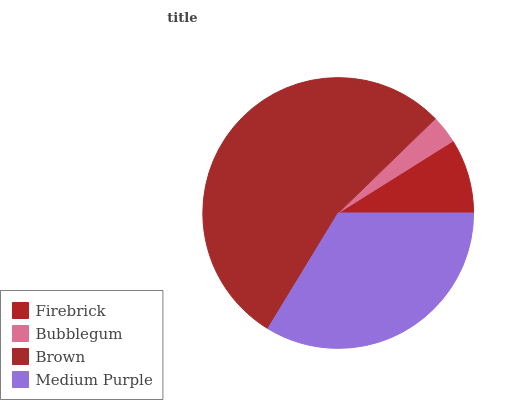Is Bubblegum the minimum?
Answer yes or no. Yes. Is Brown the maximum?
Answer yes or no. Yes. Is Brown the minimum?
Answer yes or no. No. Is Bubblegum the maximum?
Answer yes or no. No. Is Brown greater than Bubblegum?
Answer yes or no. Yes. Is Bubblegum less than Brown?
Answer yes or no. Yes. Is Bubblegum greater than Brown?
Answer yes or no. No. Is Brown less than Bubblegum?
Answer yes or no. No. Is Medium Purple the high median?
Answer yes or no. Yes. Is Firebrick the low median?
Answer yes or no. Yes. Is Firebrick the high median?
Answer yes or no. No. Is Bubblegum the low median?
Answer yes or no. No. 